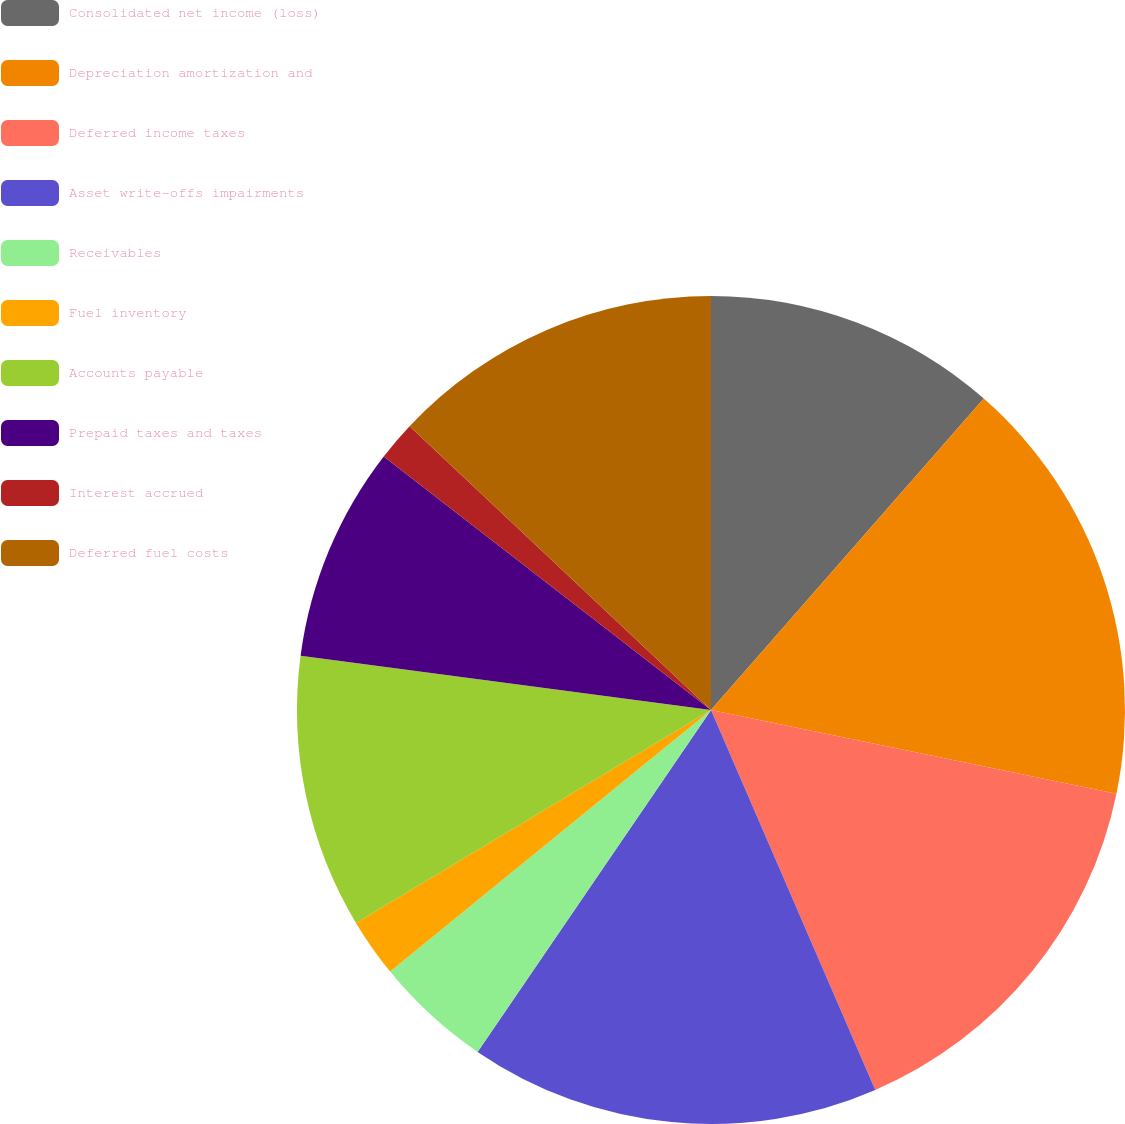Convert chart. <chart><loc_0><loc_0><loc_500><loc_500><pie_chart><fcel>Consolidated net income (loss)<fcel>Depreciation amortization and<fcel>Deferred income taxes<fcel>Asset write-offs impairments<fcel>Receivables<fcel>Fuel inventory<fcel>Accounts payable<fcel>Prepaid taxes and taxes<fcel>Interest accrued<fcel>Deferred fuel costs<nl><fcel>11.45%<fcel>16.79%<fcel>15.27%<fcel>16.03%<fcel>4.58%<fcel>2.29%<fcel>10.69%<fcel>8.4%<fcel>1.53%<fcel>12.98%<nl></chart> 